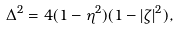<formula> <loc_0><loc_0><loc_500><loc_500>\Delta ^ { 2 } = 4 ( 1 - \eta ^ { 2 } ) ( 1 - | \zeta | ^ { 2 } ) ,</formula> 